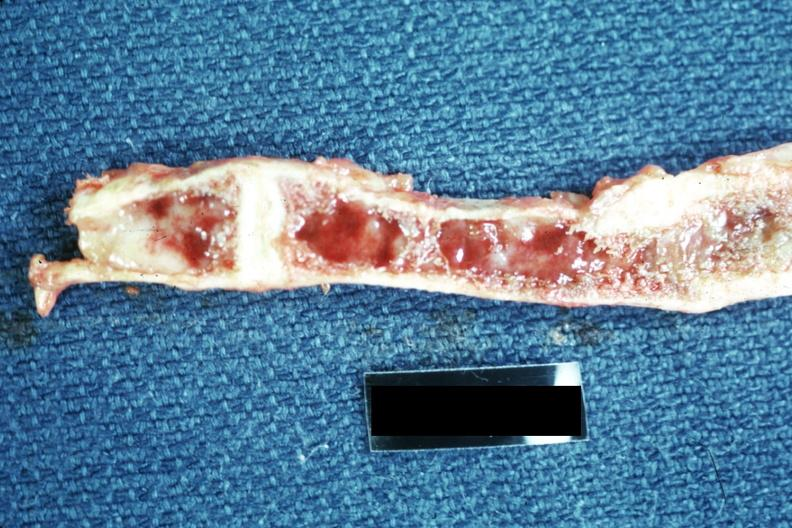what is present?
Answer the question using a single word or phrase. Joints 